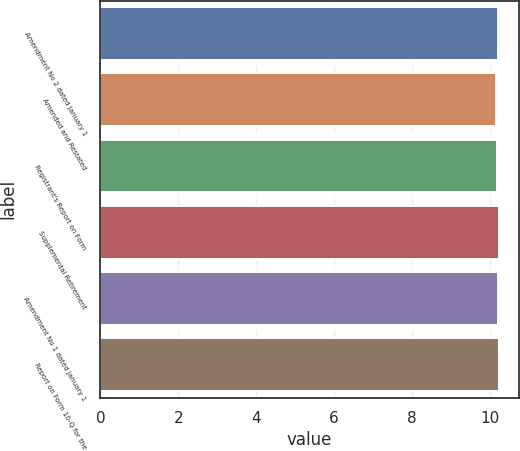Convert chart to OTSL. <chart><loc_0><loc_0><loc_500><loc_500><bar_chart><fcel>Amendment No 2 dated January 1<fcel>Amended and Restated<fcel>Registrant's Report on Form<fcel>Supplemental Retirement<fcel>Amendment No 1 dated January 1<fcel>Report on Form 10-Q for the<nl><fcel>10.22<fcel>10.17<fcel>10.18<fcel>10.23<fcel>10.21<fcel>10.24<nl></chart> 